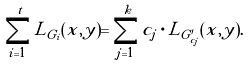Convert formula to latex. <formula><loc_0><loc_0><loc_500><loc_500>\sum _ { i = 1 } ^ { t } L _ { G _ { i } } ( x , y ) = \sum _ { j = 1 } ^ { k } c _ { j } \cdot L _ { G _ { c _ { j } } ^ { \prime } } ( x , y ) .</formula> 